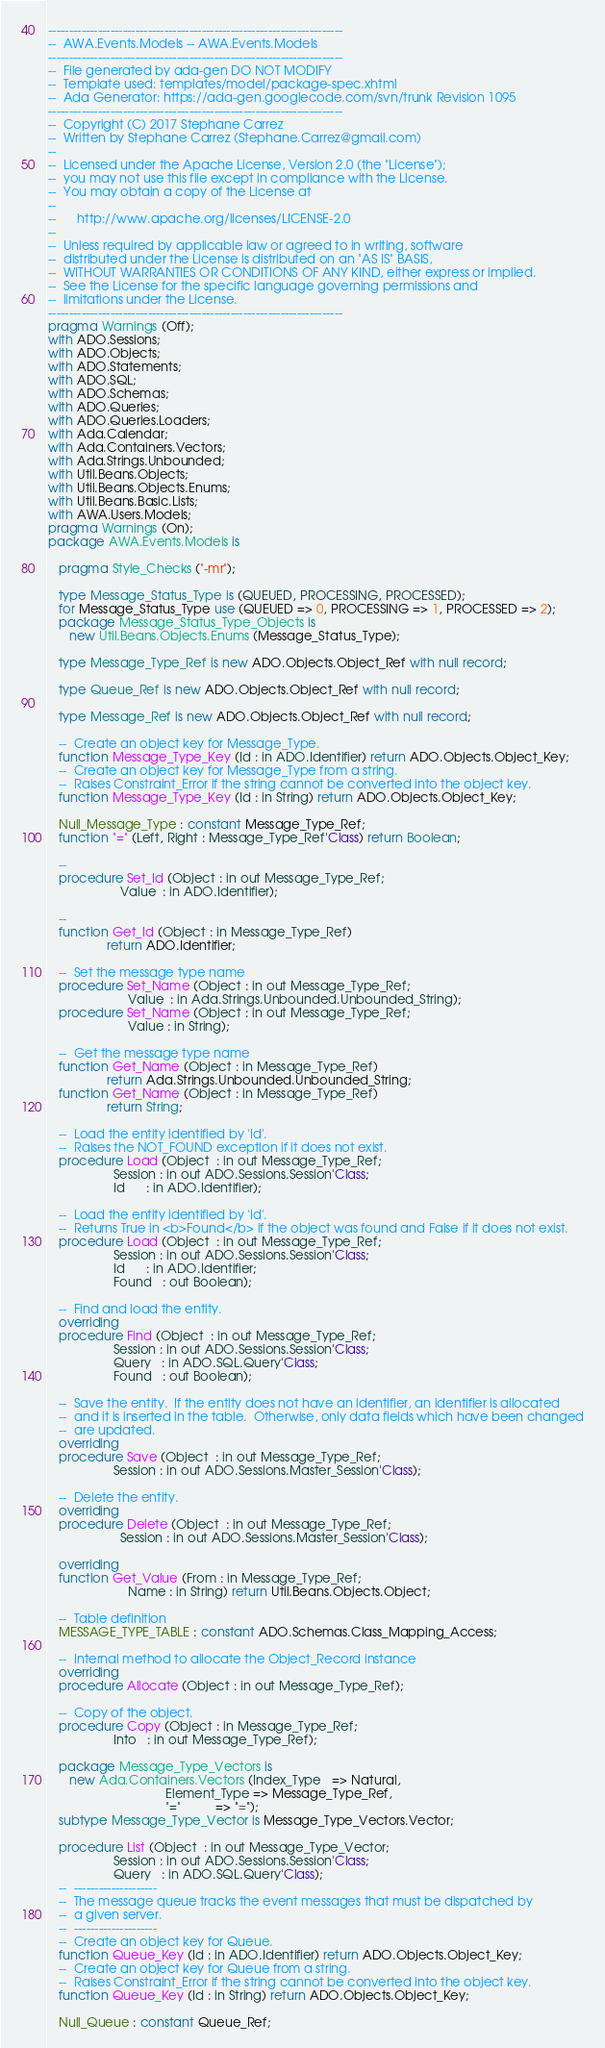<code> <loc_0><loc_0><loc_500><loc_500><_Ada_>-----------------------------------------------------------------------
--  AWA.Events.Models -- AWA.Events.Models
-----------------------------------------------------------------------
--  File generated by ada-gen DO NOT MODIFY
--  Template used: templates/model/package-spec.xhtml
--  Ada Generator: https://ada-gen.googlecode.com/svn/trunk Revision 1095
-----------------------------------------------------------------------
--  Copyright (C) 2017 Stephane Carrez
--  Written by Stephane Carrez (Stephane.Carrez@gmail.com)
--
--  Licensed under the Apache License, Version 2.0 (the "License");
--  you may not use this file except in compliance with the License.
--  You may obtain a copy of the License at
--
--      http://www.apache.org/licenses/LICENSE-2.0
--
--  Unless required by applicable law or agreed to in writing, software
--  distributed under the License is distributed on an "AS IS" BASIS,
--  WITHOUT WARRANTIES OR CONDITIONS OF ANY KIND, either express or implied.
--  See the License for the specific language governing permissions and
--  limitations under the License.
-----------------------------------------------------------------------
pragma Warnings (Off);
with ADO.Sessions;
with ADO.Objects;
with ADO.Statements;
with ADO.SQL;
with ADO.Schemas;
with ADO.Queries;
with ADO.Queries.Loaders;
with Ada.Calendar;
with Ada.Containers.Vectors;
with Ada.Strings.Unbounded;
with Util.Beans.Objects;
with Util.Beans.Objects.Enums;
with Util.Beans.Basic.Lists;
with AWA.Users.Models;
pragma Warnings (On);
package AWA.Events.Models is

   pragma Style_Checks ("-mr");

   type Message_Status_Type is (QUEUED, PROCESSING, PROCESSED);
   for Message_Status_Type use (QUEUED => 0, PROCESSING => 1, PROCESSED => 2);
   package Message_Status_Type_Objects is
      new Util.Beans.Objects.Enums (Message_Status_Type);

   type Message_Type_Ref is new ADO.Objects.Object_Ref with null record;

   type Queue_Ref is new ADO.Objects.Object_Ref with null record;

   type Message_Ref is new ADO.Objects.Object_Ref with null record;

   --  Create an object key for Message_Type.
   function Message_Type_Key (Id : in ADO.Identifier) return ADO.Objects.Object_Key;
   --  Create an object key for Message_Type from a string.
   --  Raises Constraint_Error if the string cannot be converted into the object key.
   function Message_Type_Key (Id : in String) return ADO.Objects.Object_Key;

   Null_Message_Type : constant Message_Type_Ref;
   function "=" (Left, Right : Message_Type_Ref'Class) return Boolean;

   --
   procedure Set_Id (Object : in out Message_Type_Ref;
                     Value  : in ADO.Identifier);

   --
   function Get_Id (Object : in Message_Type_Ref)
                 return ADO.Identifier;

   --  Set the message type name
   procedure Set_Name (Object : in out Message_Type_Ref;
                       Value  : in Ada.Strings.Unbounded.Unbounded_String);
   procedure Set_Name (Object : in out Message_Type_Ref;
                       Value : in String);

   --  Get the message type name
   function Get_Name (Object : in Message_Type_Ref)
                 return Ada.Strings.Unbounded.Unbounded_String;
   function Get_Name (Object : in Message_Type_Ref)
                 return String;

   --  Load the entity identified by 'Id'.
   --  Raises the NOT_FOUND exception if it does not exist.
   procedure Load (Object  : in out Message_Type_Ref;
                   Session : in out ADO.Sessions.Session'Class;
                   Id      : in ADO.Identifier);

   --  Load the entity identified by 'Id'.
   --  Returns True in <b>Found</b> if the object was found and False if it does not exist.
   procedure Load (Object  : in out Message_Type_Ref;
                   Session : in out ADO.Sessions.Session'Class;
                   Id      : in ADO.Identifier;
                   Found   : out Boolean);

   --  Find and load the entity.
   overriding
   procedure Find (Object  : in out Message_Type_Ref;
                   Session : in out ADO.Sessions.Session'Class;
                   Query   : in ADO.SQL.Query'Class;
                   Found   : out Boolean);

   --  Save the entity.  If the entity does not have an identifier, an identifier is allocated
   --  and it is inserted in the table.  Otherwise, only data fields which have been changed
   --  are updated.
   overriding
   procedure Save (Object  : in out Message_Type_Ref;
                   Session : in out ADO.Sessions.Master_Session'Class);

   --  Delete the entity.
   overriding
   procedure Delete (Object  : in out Message_Type_Ref;
                     Session : in out ADO.Sessions.Master_Session'Class);

   overriding
   function Get_Value (From : in Message_Type_Ref;
                       Name : in String) return Util.Beans.Objects.Object;

   --  Table definition
   MESSAGE_TYPE_TABLE : constant ADO.Schemas.Class_Mapping_Access;

   --  Internal method to allocate the Object_Record instance
   overriding
   procedure Allocate (Object : in out Message_Type_Ref);

   --  Copy of the object.
   procedure Copy (Object : in Message_Type_Ref;
                   Into   : in out Message_Type_Ref);

   package Message_Type_Vectors is
      new Ada.Containers.Vectors (Index_Type   => Natural,
                                  Element_Type => Message_Type_Ref,
                                  "="          => "=");
   subtype Message_Type_Vector is Message_Type_Vectors.Vector;

   procedure List (Object  : in out Message_Type_Vector;
                   Session : in out ADO.Sessions.Session'Class;
                   Query   : in ADO.SQL.Query'Class);
   --  --------------------
   --  The message queue tracks the event messages that must be dispatched by
   --  a given server.
   --  --------------------
   --  Create an object key for Queue.
   function Queue_Key (Id : in ADO.Identifier) return ADO.Objects.Object_Key;
   --  Create an object key for Queue from a string.
   --  Raises Constraint_Error if the string cannot be converted into the object key.
   function Queue_Key (Id : in String) return ADO.Objects.Object_Key;

   Null_Queue : constant Queue_Ref;</code> 